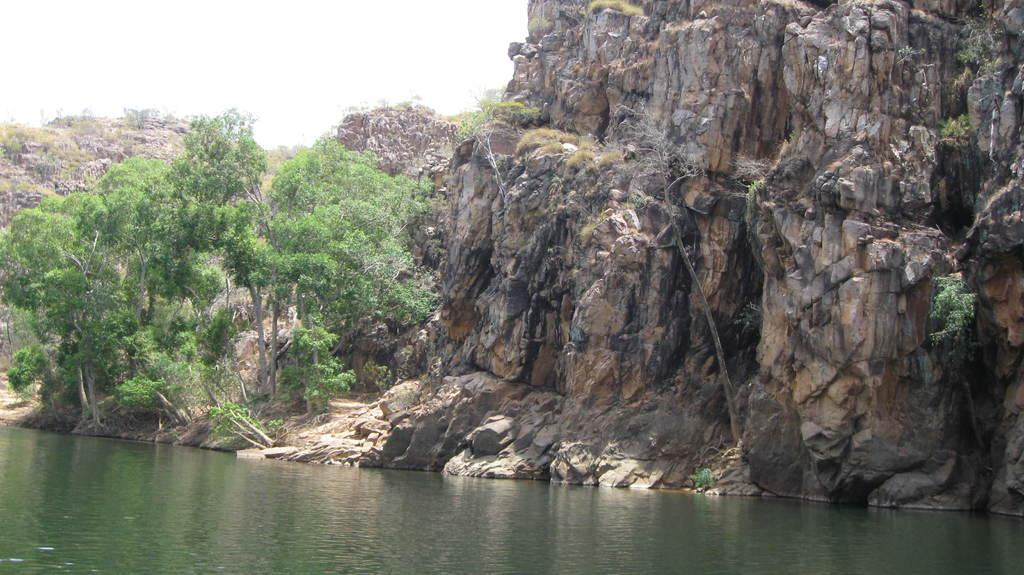What is present at the bottom of the image? There is water at the bottom of the image. What can be seen on the left side of the image? There are trees on the left side of the image. What is visible at the top of the image? The sky is visible at the top of the image. What type of pipe is visible in the image? There is no pipe present in the image. What color is the dress worn by the tree on the left side of the image? There is no dress present in the image, as the trees are not wearing any clothing. 